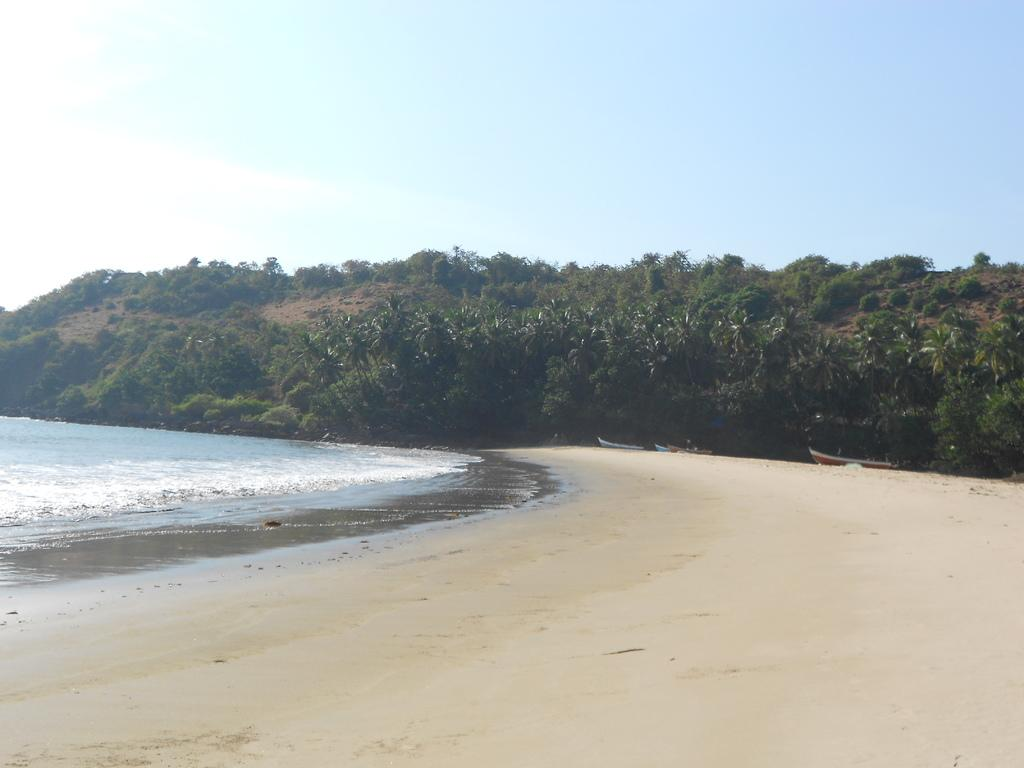What can be seen in the foreground of the picture? There are boats, sand, and water in the foreground of the picture. What is located in the center of the picture? There are trees and plants in the center of the picture. What is the condition of the sky in the picture? The sky is clear in the picture. What is the weather like in the image? It is sunny in the image. Can you tell me how many tomatoes are growing on the trees in the image? There are no tomatoes present in the image; the trees have leaves and possibly other types of plants. What type of step is visible in the image? There is no step visible in the image; the focus is on the boats, sand, water, trees, plants, sky, and weather. 